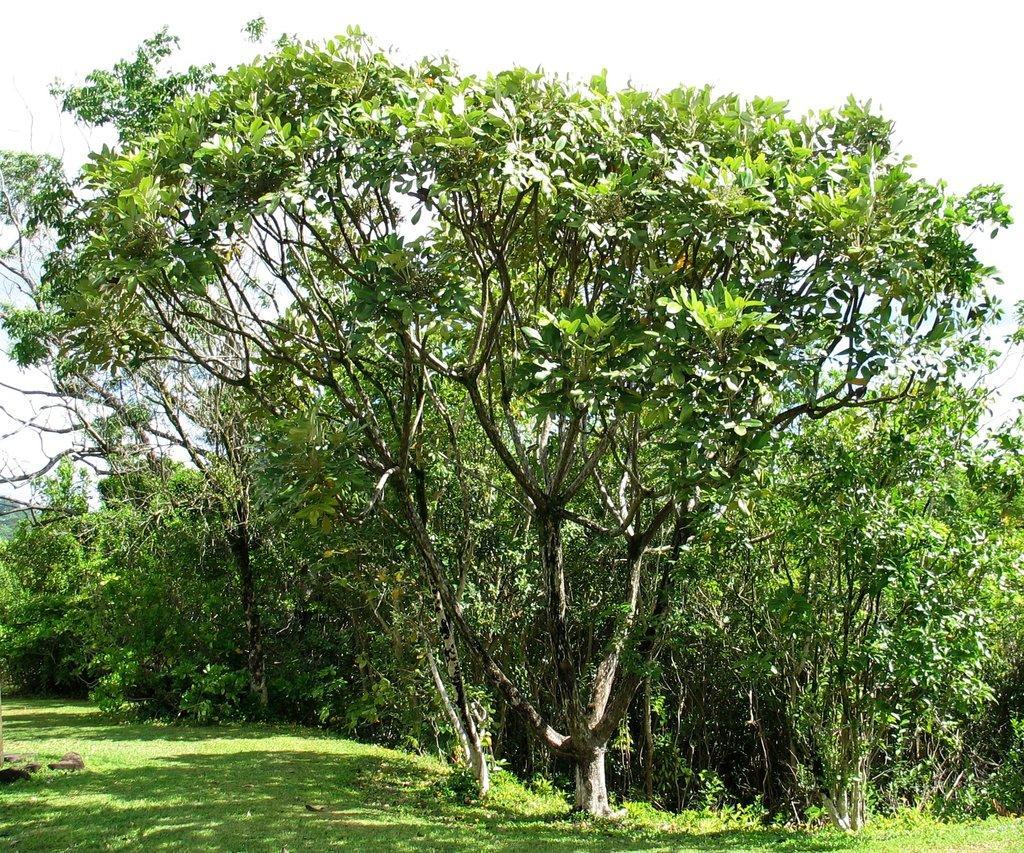What type of vegetation is present at the bottom of the image? There is grass on the ground at the bottom of the image. What else can be seen on the ground in the image? There are many trees on the ground. What is visible in the background of the image? The sky is visible in the background of the image. How many pigs are playing on the playground in the image? There is no playground or pigs present in the image. What type of feather can be seen falling from the sky in the image? There is no feather visible in the image; only grass, trees, and the sky are present. 